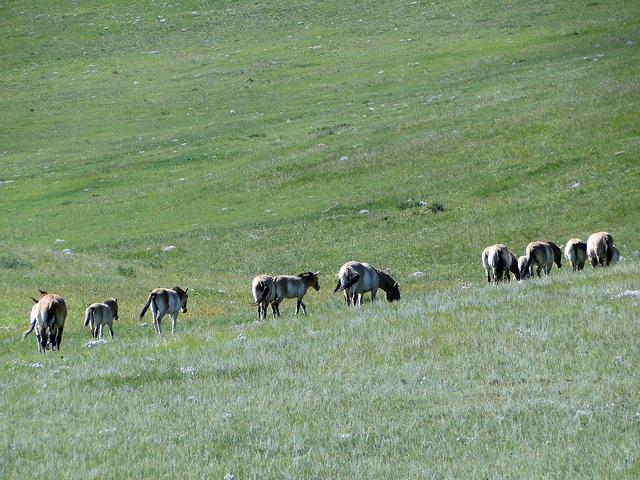Are all the animals the same color?
Keep it brief. Yes. What is this terrain like?
Write a very short answer. Hilly. What are the animals in the image eating?
Concise answer only. Grass. 